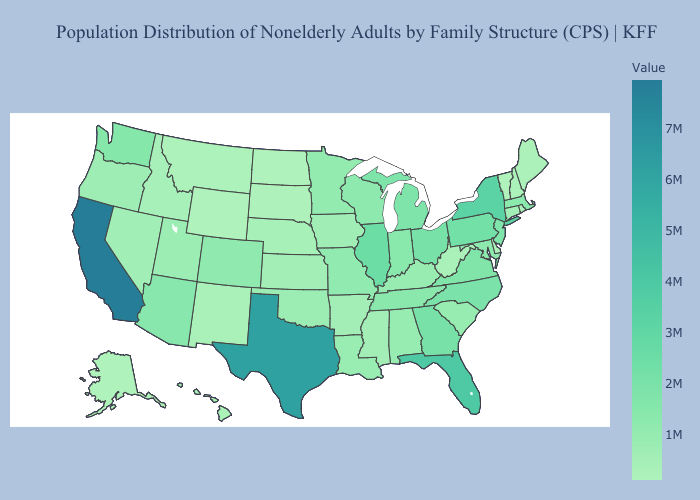Does Kentucky have a lower value than Texas?
Give a very brief answer. Yes. Does California have the highest value in the USA?
Give a very brief answer. Yes. Among the states that border Minnesota , which have the highest value?
Short answer required. Wisconsin. Which states have the highest value in the USA?
Concise answer only. California. Does Colorado have the lowest value in the West?
Give a very brief answer. No. Does Wisconsin have a higher value than New York?
Quick response, please. No. 